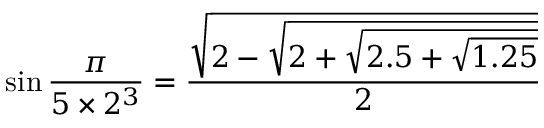Convert formula to latex. <formula><loc_0><loc_0><loc_500><loc_500>\sin { \frac { \pi } { 5 \times 2 ^ { 3 } } } = { \frac { \sqrt { 2 - { \sqrt { 2 + { \sqrt { 2 . 5 + { \sqrt { 1 . 2 5 } } } } } } } } { 2 } }</formula> 